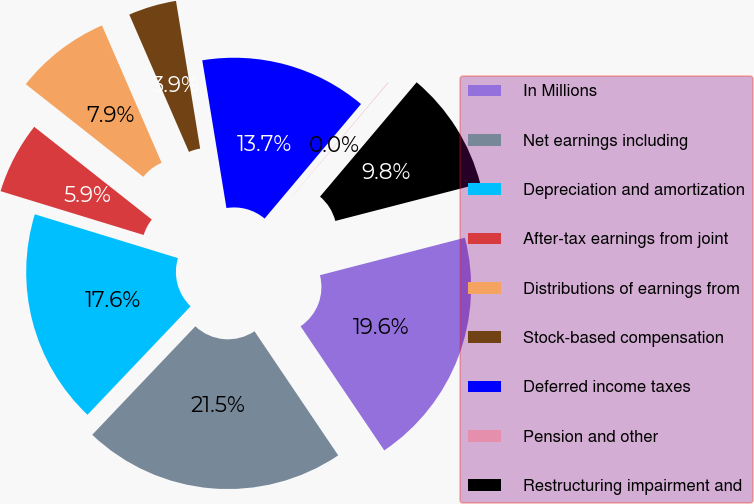Convert chart to OTSL. <chart><loc_0><loc_0><loc_500><loc_500><pie_chart><fcel>In Millions<fcel>Net earnings including<fcel>Depreciation and amortization<fcel>After-tax earnings from joint<fcel>Distributions of earnings from<fcel>Stock-based compensation<fcel>Deferred income taxes<fcel>Pension and other<fcel>Restructuring impairment and<nl><fcel>19.58%<fcel>21.54%<fcel>17.63%<fcel>5.9%<fcel>7.85%<fcel>3.94%<fcel>13.72%<fcel>0.03%<fcel>9.81%<nl></chart> 